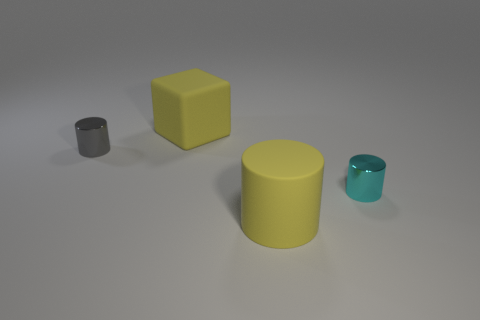What shape is the gray thing that is the same size as the cyan object? cylinder 